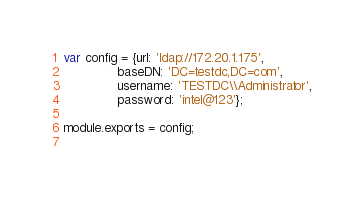<code> <loc_0><loc_0><loc_500><loc_500><_JavaScript_>var config = {url: 'ldap://172.20.1.175',
              baseDN: 'DC=testdc,DC=com',
              username: 'TESTDC\\Administrator',
              password: 'intel@123'};

module.exports = config;
 </code> 